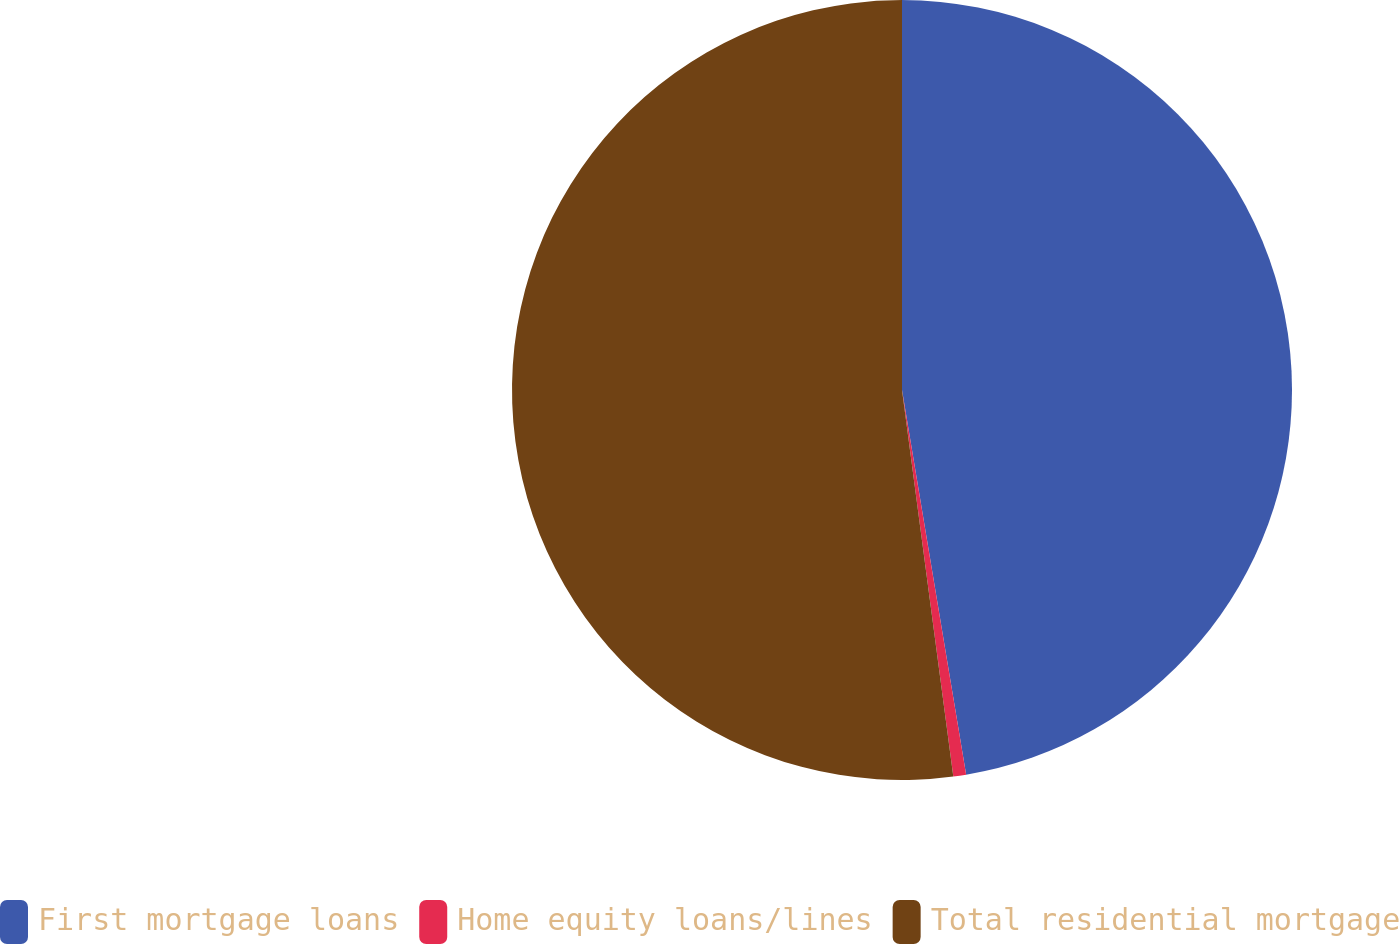Convert chart to OTSL. <chart><loc_0><loc_0><loc_500><loc_500><pie_chart><fcel>First mortgage loans<fcel>Home equity loans/lines<fcel>Total residential mortgage<nl><fcel>47.37%<fcel>0.53%<fcel>52.1%<nl></chart> 